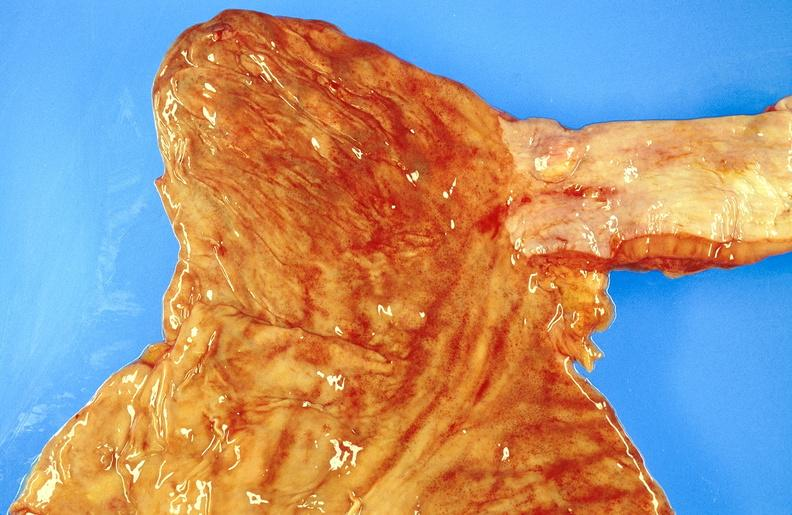s intrauterine contraceptive device present?
Answer the question using a single word or phrase. No 